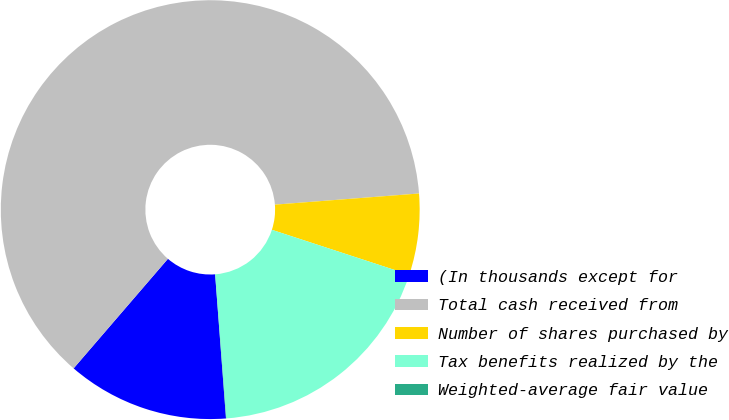Convert chart to OTSL. <chart><loc_0><loc_0><loc_500><loc_500><pie_chart><fcel>(In thousands except for<fcel>Total cash received from<fcel>Number of shares purchased by<fcel>Tax benefits realized by the<fcel>Weighted-average fair value<nl><fcel>12.51%<fcel>62.46%<fcel>6.26%<fcel>18.75%<fcel>0.02%<nl></chart> 